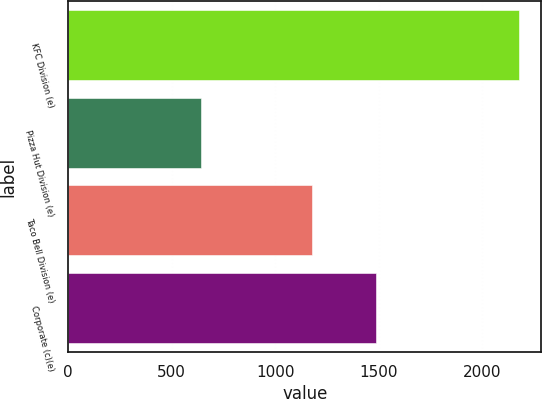Convert chart to OTSL. <chart><loc_0><loc_0><loc_500><loc_500><bar_chart><fcel>KFC Division (e)<fcel>Pizza Hut Division (e)<fcel>Taco Bell Division (e)<fcel>Corporate (c)(e)<nl><fcel>2176<fcel>639<fcel>1178<fcel>1485<nl></chart> 